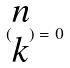Convert formula to latex. <formula><loc_0><loc_0><loc_500><loc_500>( \begin{matrix} n \\ k \end{matrix} ) = 0</formula> 